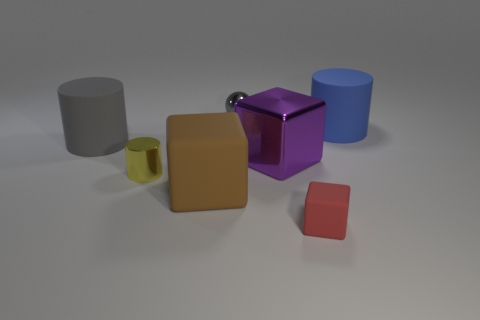Do the big rubber cylinder to the left of the yellow shiny cylinder and the tiny ball have the same color?
Make the answer very short. Yes. Does the ball have the same color as the large cylinder that is to the left of the brown cube?
Provide a succinct answer. Yes. What number of metallic things are either small red things or brown cylinders?
Give a very brief answer. 0. Are there any other large cylinders that have the same material as the large blue cylinder?
Keep it short and to the point. Yes. What is the purple block made of?
Keep it short and to the point. Metal. What is the shape of the tiny thing that is behind the tiny shiny thing to the left of the tiny shiny object that is behind the big gray rubber thing?
Your answer should be compact. Sphere. Is the number of objects that are behind the tiny yellow metal cylinder greater than the number of small purple objects?
Your response must be concise. Yes. There is a gray rubber object; is its shape the same as the tiny thing that is right of the purple object?
Provide a succinct answer. No. There is a big rubber object that is the same color as the small ball; what is its shape?
Keep it short and to the point. Cylinder. What number of tiny gray shiny spheres are on the left side of the small metal object that is behind the matte cylinder that is on the left side of the large matte cube?
Make the answer very short. 0. 